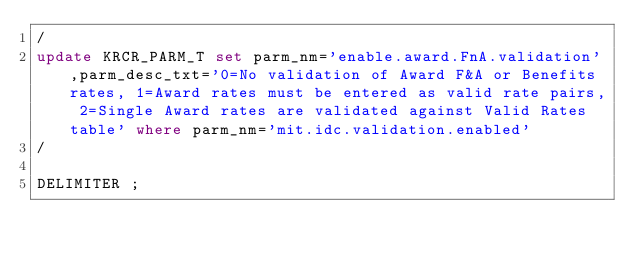<code> <loc_0><loc_0><loc_500><loc_500><_SQL_>/
update KRCR_PARM_T set parm_nm='enable.award.FnA.validation',parm_desc_txt='0=No validation of Award F&A or Benefits rates, 1=Award rates must be entered as valid rate pairs, 2=Single Award rates are validated against Valid Rates table' where parm_nm='mit.idc.validation.enabled'
/

DELIMITER ;
</code> 